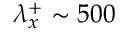Convert formula to latex. <formula><loc_0><loc_0><loc_500><loc_500>\lambda _ { x } ^ { + } \sim 5 0 0</formula> 